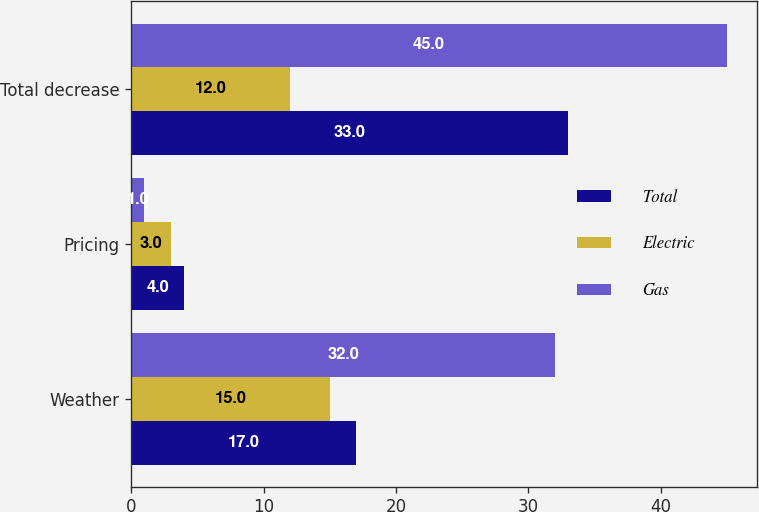Convert chart. <chart><loc_0><loc_0><loc_500><loc_500><stacked_bar_chart><ecel><fcel>Weather<fcel>Pricing<fcel>Total decrease<nl><fcel>Total<fcel>17<fcel>4<fcel>33<nl><fcel>Electric<fcel>15<fcel>3<fcel>12<nl><fcel>Gas<fcel>32<fcel>1<fcel>45<nl></chart> 